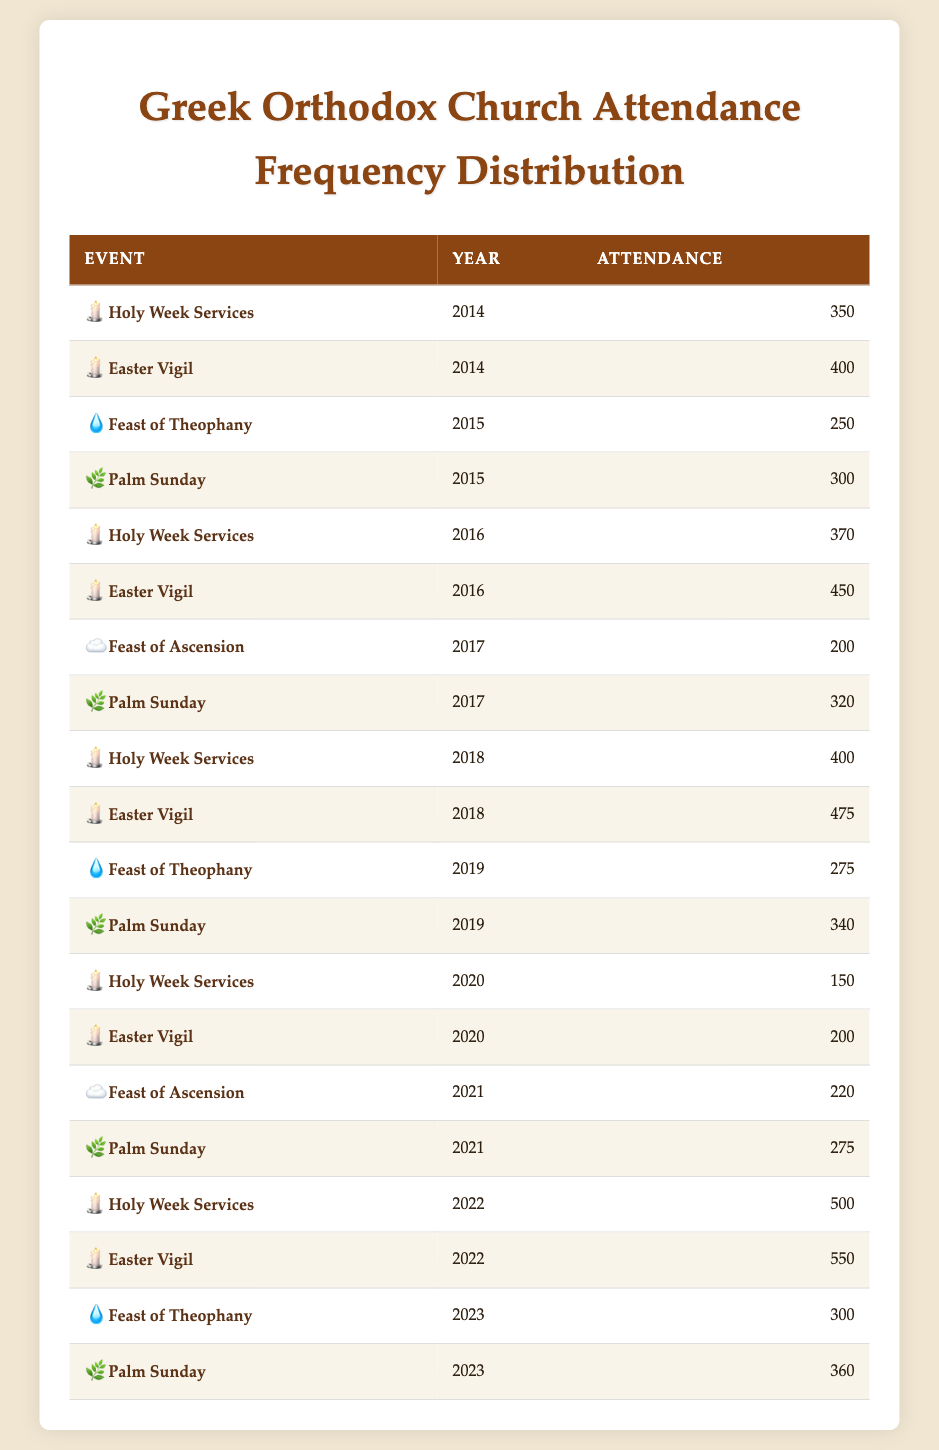What was the attendance for the Easter Vigil in 2018? In the table, I can locate the row where the event is "Easter Vigil" and the year is 2018. The attendance for this event in that year is stated as 475.
Answer: 475 What was the highest attendance recorded for Holy Week Services? I will scan the rows for the "Holy Week Services" event and find the highest attendance figure. The highest recorded attendance appears in 2022 with an attendance of 500.
Answer: 500 Was the attendance for the Feast of Ascension higher in 2021 than in 2017? For 2021, the attendance for the Feast of Ascension was 220, while in 2017 it was 200. Since 220 is greater than 200, the attendance in 2021 was indeed higher.
Answer: Yes How many attendees were there in total for Palm Sunday across all years? I will sum the attendance figures for each Palm Sunday listed: 300 (2015) + 320 (2017) + 340 (2019) + 275 (2021) + 360 (2023) = 1575. Thus, the total attendance across all years is 1575.
Answer: 1575 What year had the lowest attendance for the Holy Week Services? By examining the attendance figures for Holy Week Services across the years, the lowest attendance appears in 2020, where only 150 attended.
Answer: 2020 How does the attendance for the Easter Vigil in 2022 compare to the previous years? For the Easter Vigil in 2022, the attendance was 550. Looking at the previous years: 400 (2014), 450 (2016), 475 (2018), and 200 (2020). 550 is higher than all of these figures, making it the highest attendance recorded for this event.
Answer: Highest Which event had the highest attendance in 2022? I will look at the attendance figures for 2022. The Holy Week Services had 500 attendees, and the Easter Vigil had 550 attendees in that year, making the Easter Vigil the event with the highest attendance in 2022.
Answer: Easter Vigil In which year did the Feast of Theophany have an attendance of 275? Scanning the table for the Feast of Theophany, I can find that the attendance of 275 occurred in 2019.
Answer: 2019 Did the attendance for the Holy Week Services increase from 2016 to 2018? In 2016, the attendance for Holy Week Services was 370, and in 2018 it was 400. Since 400 is greater than 370, this illustrates an increase in attendance during those years.
Answer: Yes 